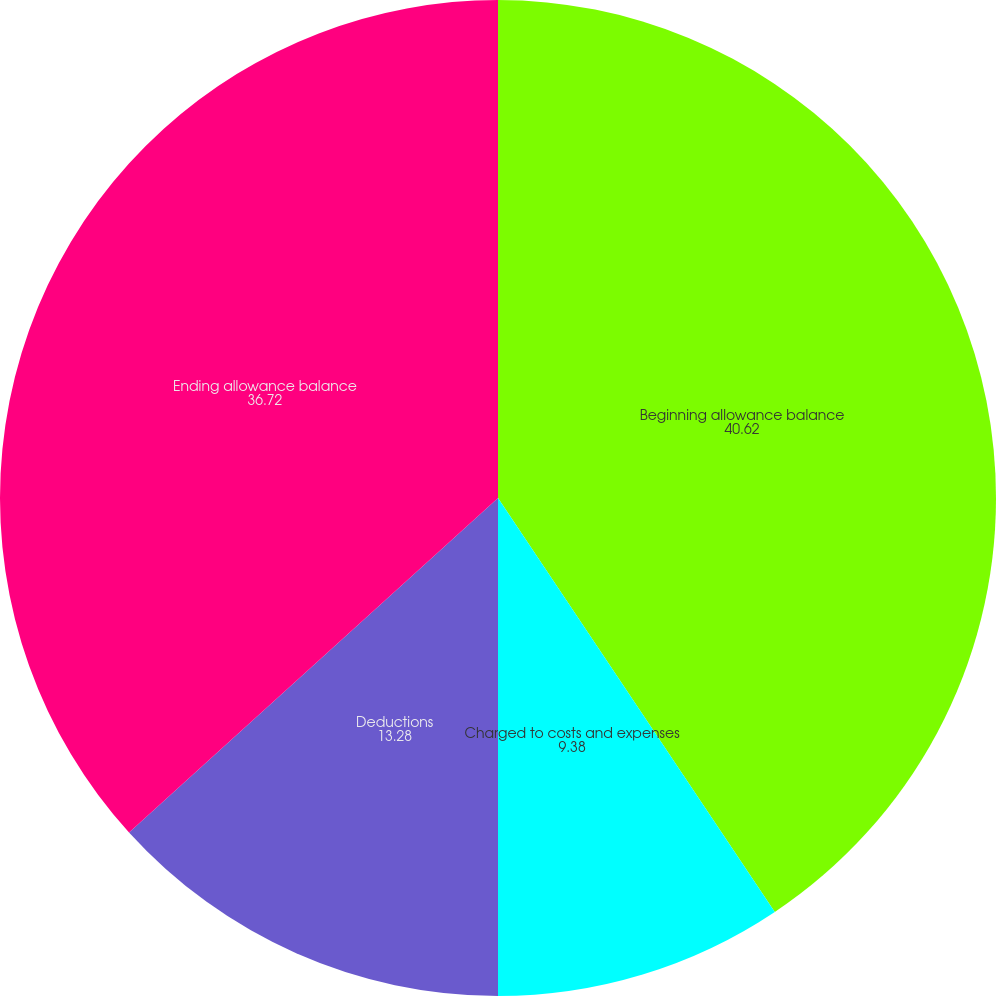Convert chart. <chart><loc_0><loc_0><loc_500><loc_500><pie_chart><fcel>Beginning allowance balance<fcel>Charged to costs and expenses<fcel>Deductions<fcel>Ending allowance balance<nl><fcel>40.62%<fcel>9.38%<fcel>13.28%<fcel>36.72%<nl></chart> 